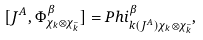Convert formula to latex. <formula><loc_0><loc_0><loc_500><loc_500>[ J ^ { A } , \Phi _ { \chi _ { k } \otimes \chi _ { \bar { k } } } ^ { \beta } ] = P h i _ { k ( J ^ { A } ) \chi _ { k } \otimes \chi _ { \bar { k } } } ^ { \beta } ,</formula> 